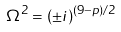Convert formula to latex. <formula><loc_0><loc_0><loc_500><loc_500>\Omega ^ { 2 } = ( \pm i ) ^ { ( 9 - p ) / 2 }</formula> 